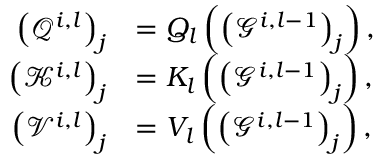<formula> <loc_0><loc_0><loc_500><loc_500>\begin{array} { r l } { \left ( \mathcal { Q } ^ { i , l } \right ) _ { j } } & { = Q _ { l } \left ( \left ( \mathcal { G } ^ { i , l - 1 } \right ) _ { j } \right ) , } \\ { \left ( \mathcal { K } ^ { i , l } \right ) _ { j } } & { = K _ { l } \left ( \left ( \mathcal { G } ^ { i , l - 1 } \right ) _ { j } \right ) , } \\ { \left ( \mathcal { V } ^ { i , l } \right ) _ { j } } & { = V _ { l } \left ( \left ( \mathcal { G } ^ { i , l - 1 } \right ) _ { j } \right ) , } \end{array}</formula> 